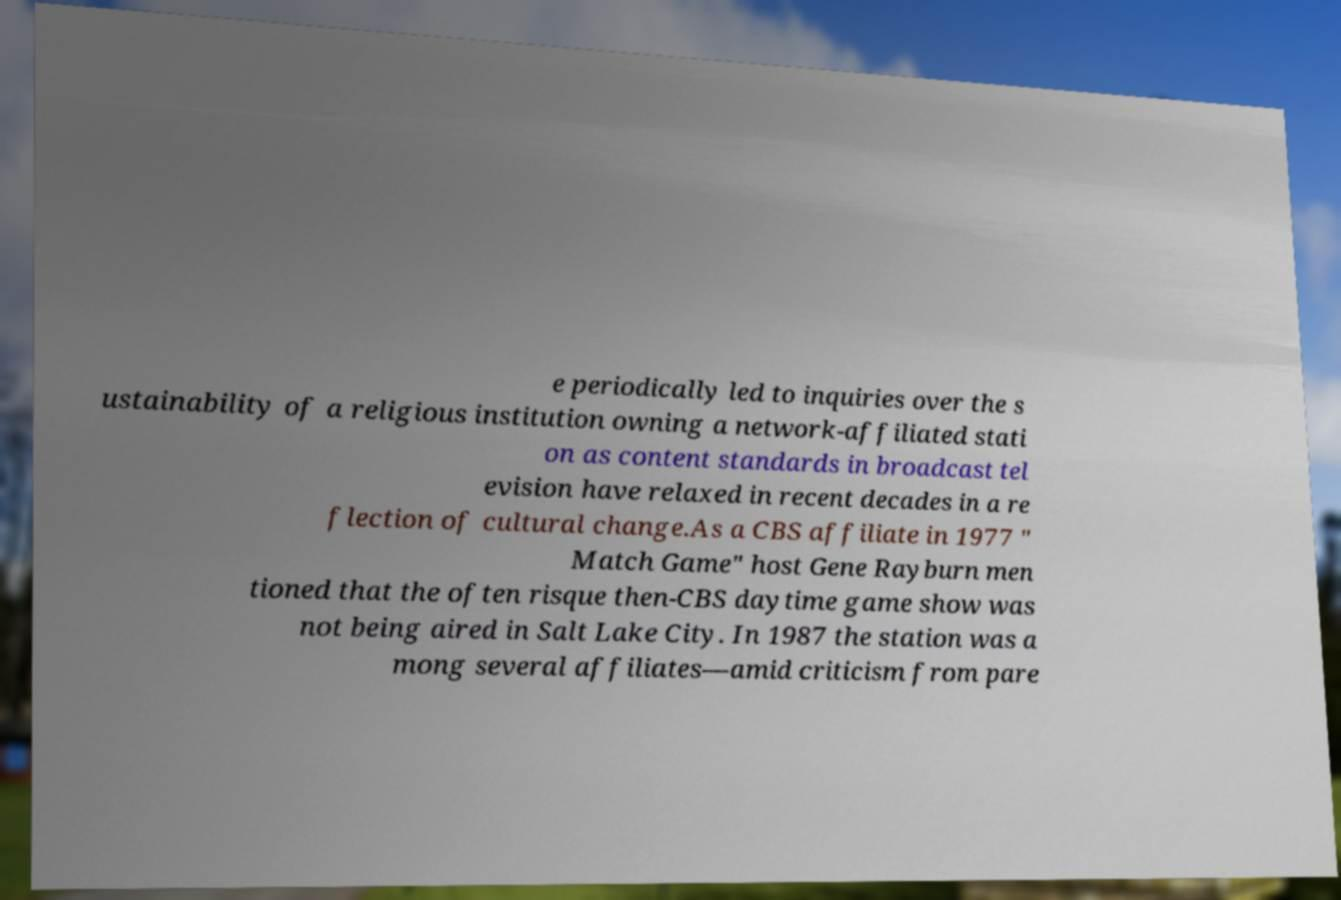What messages or text are displayed in this image? I need them in a readable, typed format. e periodically led to inquiries over the s ustainability of a religious institution owning a network-affiliated stati on as content standards in broadcast tel evision have relaxed in recent decades in a re flection of cultural change.As a CBS affiliate in 1977 " Match Game" host Gene Rayburn men tioned that the often risque then-CBS daytime game show was not being aired in Salt Lake City. In 1987 the station was a mong several affiliates—amid criticism from pare 